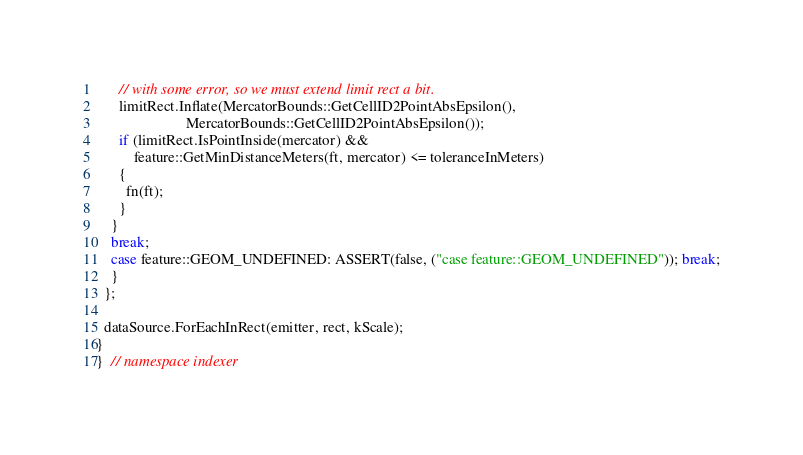<code> <loc_0><loc_0><loc_500><loc_500><_C++_>      // with some error, so we must extend limit rect a bit.
      limitRect.Inflate(MercatorBounds::GetCellID2PointAbsEpsilon(),
                        MercatorBounds::GetCellID2PointAbsEpsilon());
      if (limitRect.IsPointInside(mercator) &&
          feature::GetMinDistanceMeters(ft, mercator) <= toleranceInMeters)
      {
        fn(ft);
      }
    }
    break;
    case feature::GEOM_UNDEFINED: ASSERT(false, ("case feature::GEOM_UNDEFINED")); break;
    }
  };

  dataSource.ForEachInRect(emitter, rect, kScale);
}
}  // namespace indexer
</code> 